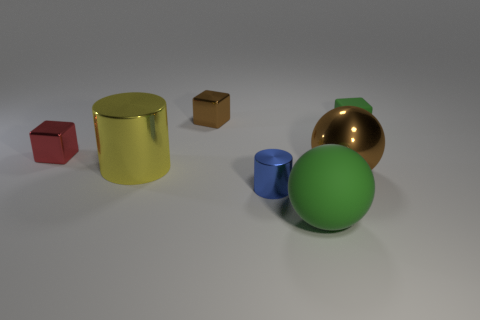What is the shape of the small green rubber thing?
Keep it short and to the point. Cube. How many other things are there of the same material as the large brown ball?
Your answer should be very brief. 4. What is the color of the small metallic thing to the right of the brown thing behind the metal block in front of the tiny brown shiny thing?
Your answer should be compact. Blue. What material is the brown object that is the same size as the yellow metallic thing?
Offer a very short reply. Metal. How many things are small metal objects in front of the red cube or matte things?
Offer a very short reply. 3. Are there any large cylinders?
Make the answer very short. Yes. There is a brown object that is in front of the yellow metal cylinder; what is it made of?
Offer a very short reply. Metal. There is a small cube that is the same color as the metal ball; what is it made of?
Provide a succinct answer. Metal. How many small objects are blue things or blocks?
Ensure brevity in your answer.  4. What color is the large metallic cylinder?
Provide a succinct answer. Yellow. 